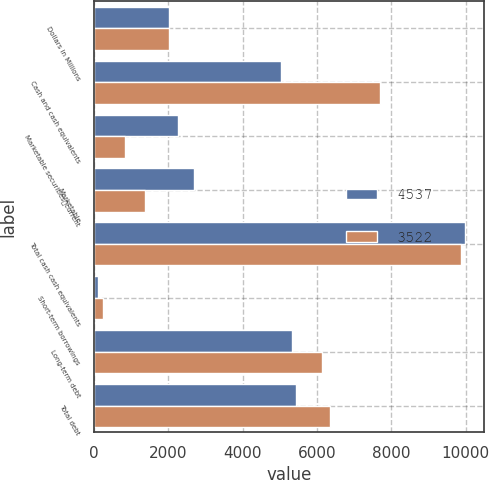<chart> <loc_0><loc_0><loc_500><loc_500><stacked_bar_chart><ecel><fcel>Dollars in Millions<fcel>Cash and cash equivalents<fcel>Marketable securitiescurrent<fcel>Marketable<fcel>Total cash cash equivalents<fcel>Short-term borrowings<fcel>Long-term debt<fcel>Total debt<nl><fcel>4537<fcel>2010<fcel>5033<fcel>2268<fcel>2681<fcel>9982<fcel>117<fcel>5328<fcel>5445<nl><fcel>3522<fcel>2009<fcel>7683<fcel>831<fcel>1369<fcel>9883<fcel>231<fcel>6130<fcel>6361<nl></chart> 